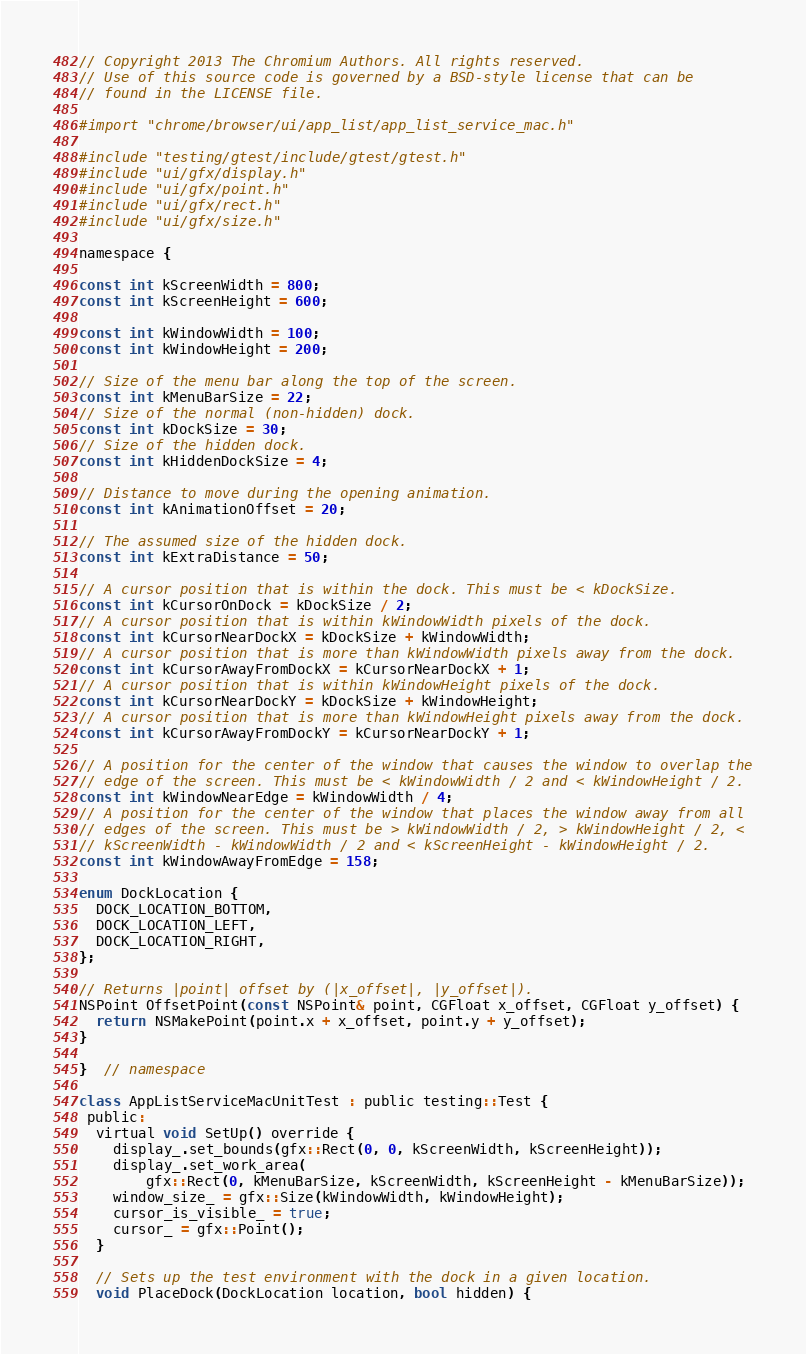Convert code to text. <code><loc_0><loc_0><loc_500><loc_500><_ObjectiveC_>// Copyright 2013 The Chromium Authors. All rights reserved.
// Use of this source code is governed by a BSD-style license that can be
// found in the LICENSE file.

#import "chrome/browser/ui/app_list/app_list_service_mac.h"

#include "testing/gtest/include/gtest/gtest.h"
#include "ui/gfx/display.h"
#include "ui/gfx/point.h"
#include "ui/gfx/rect.h"
#include "ui/gfx/size.h"

namespace {

const int kScreenWidth = 800;
const int kScreenHeight = 600;

const int kWindowWidth = 100;
const int kWindowHeight = 200;

// Size of the menu bar along the top of the screen.
const int kMenuBarSize = 22;
// Size of the normal (non-hidden) dock.
const int kDockSize = 30;
// Size of the hidden dock.
const int kHiddenDockSize = 4;

// Distance to move during the opening animation.
const int kAnimationOffset = 20;

// The assumed size of the hidden dock.
const int kExtraDistance = 50;

// A cursor position that is within the dock. This must be < kDockSize.
const int kCursorOnDock = kDockSize / 2;
// A cursor position that is within kWindowWidth pixels of the dock.
const int kCursorNearDockX = kDockSize + kWindowWidth;
// A cursor position that is more than kWindowWidth pixels away from the dock.
const int kCursorAwayFromDockX = kCursorNearDockX + 1;
// A cursor position that is within kWindowHeight pixels of the dock.
const int kCursorNearDockY = kDockSize + kWindowHeight;
// A cursor position that is more than kWindowHeight pixels away from the dock.
const int kCursorAwayFromDockY = kCursorNearDockY + 1;

// A position for the center of the window that causes the window to overlap the
// edge of the screen. This must be < kWindowWidth / 2 and < kWindowHeight / 2.
const int kWindowNearEdge = kWindowWidth / 4;
// A position for the center of the window that places the window away from all
// edges of the screen. This must be > kWindowWidth / 2, > kWindowHeight / 2, <
// kScreenWidth - kWindowWidth / 2 and < kScreenHeight - kWindowHeight / 2.
const int kWindowAwayFromEdge = 158;

enum DockLocation {
  DOCK_LOCATION_BOTTOM,
  DOCK_LOCATION_LEFT,
  DOCK_LOCATION_RIGHT,
};

// Returns |point| offset by (|x_offset|, |y_offset|).
NSPoint OffsetPoint(const NSPoint& point, CGFloat x_offset, CGFloat y_offset) {
  return NSMakePoint(point.x + x_offset, point.y + y_offset);
}

}  // namespace

class AppListServiceMacUnitTest : public testing::Test {
 public:
  virtual void SetUp() override {
    display_.set_bounds(gfx::Rect(0, 0, kScreenWidth, kScreenHeight));
    display_.set_work_area(
        gfx::Rect(0, kMenuBarSize, kScreenWidth, kScreenHeight - kMenuBarSize));
    window_size_ = gfx::Size(kWindowWidth, kWindowHeight);
    cursor_is_visible_ = true;
    cursor_ = gfx::Point();
  }

  // Sets up the test environment with the dock in a given location.
  void PlaceDock(DockLocation location, bool hidden) {</code> 